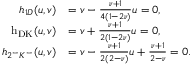<formula> <loc_0><loc_0><loc_500><loc_500>\begin{array} { r l } { h _ { 1 D } ( u , v ) } & { = v - \frac { \nu + 1 } { 4 ( 1 - 2 \nu ) } u = 0 , } \\ { { h _ { D K } } ( u , v ) } & { = v + \frac { \nu + 1 } { 2 ( 1 - 2 \nu ) } u = 0 , } \\ { h _ { 2 ^ { - } K ^ { - } } ( u , v ) } & { = v - \frac { \nu + 1 } { 2 ( 2 - \nu ) } u + \frac { \nu + 1 } { 2 - \nu } = 0 . } \end{array}</formula> 